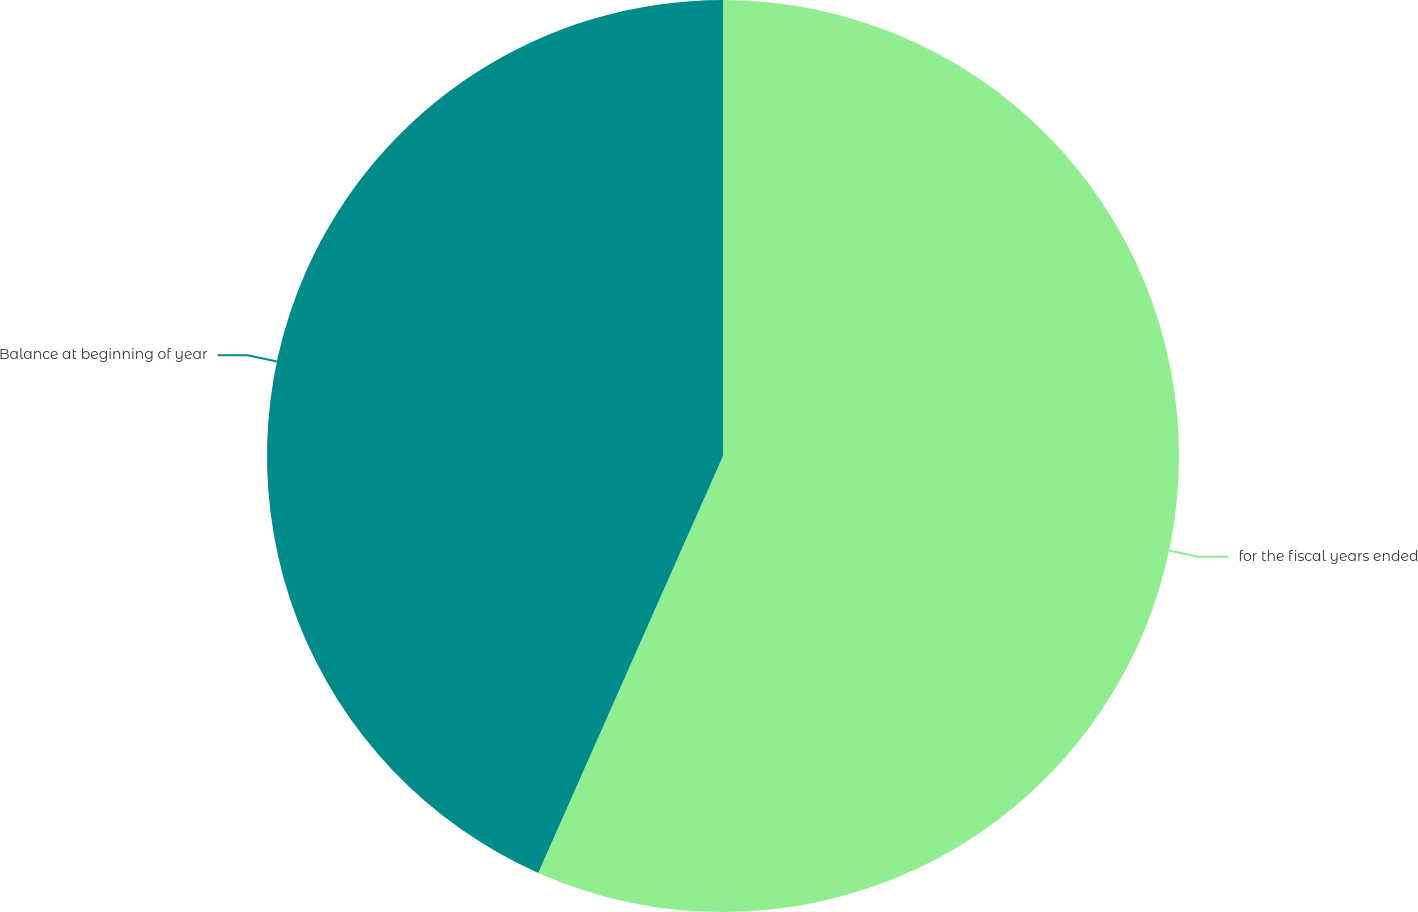Convert chart to OTSL. <chart><loc_0><loc_0><loc_500><loc_500><pie_chart><fcel>for the fiscal years ended<fcel>Balance at beginning of year<nl><fcel>56.64%<fcel>43.36%<nl></chart> 